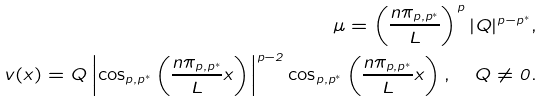Convert formula to latex. <formula><loc_0><loc_0><loc_500><loc_500>\mu = \left ( \frac { n \pi _ { p , p ^ { * } } } { L } \right ) ^ { p } | Q | ^ { p - p ^ { * } } , \\ v ( x ) = Q \left | \cos _ { p , p ^ { * } } \left ( \frac { n \pi _ { p , p ^ { * } } } { L } x \right ) \right | ^ { p - 2 } \cos _ { p , p ^ { * } } \left ( \frac { n \pi _ { p , p ^ { * } } } { L } x \right ) , \quad Q \neq 0 .</formula> 